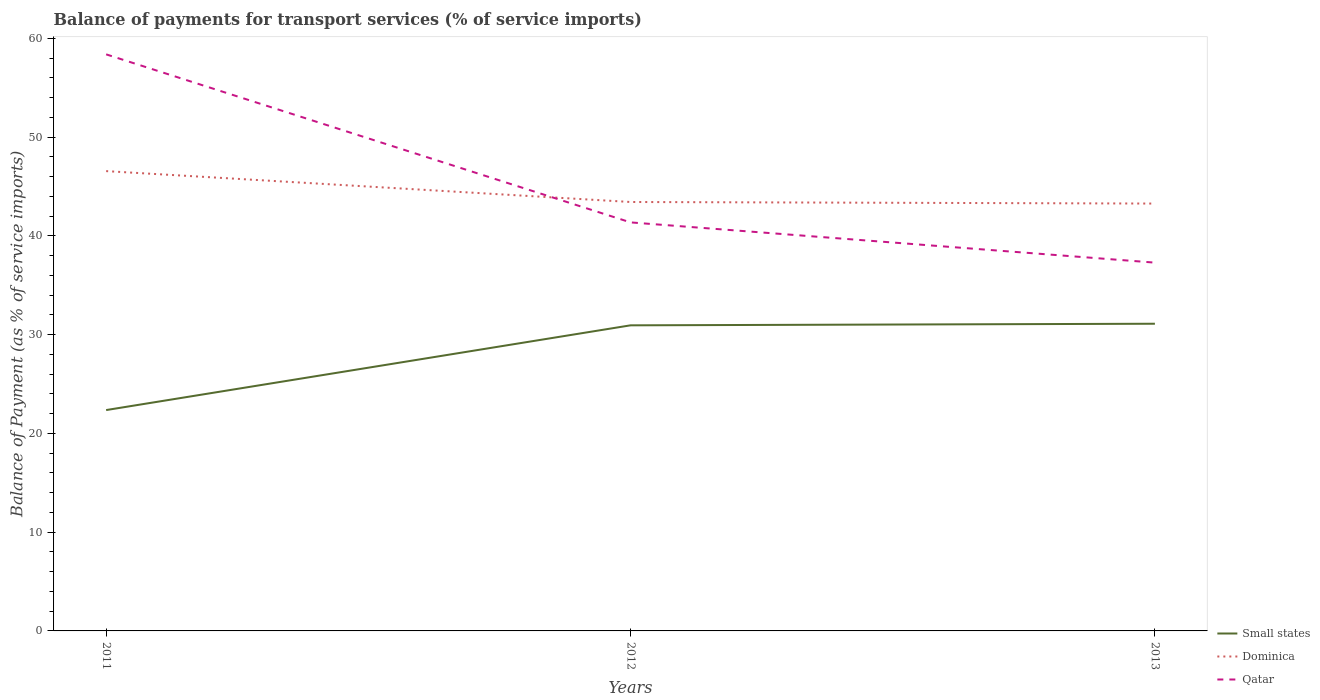Does the line corresponding to Small states intersect with the line corresponding to Qatar?
Keep it short and to the point. No. Is the number of lines equal to the number of legend labels?
Provide a short and direct response. Yes. Across all years, what is the maximum balance of payments for transport services in Small states?
Ensure brevity in your answer.  22.36. In which year was the balance of payments for transport services in Dominica maximum?
Ensure brevity in your answer.  2013. What is the total balance of payments for transport services in Dominica in the graph?
Your answer should be compact. 3.13. What is the difference between the highest and the second highest balance of payments for transport services in Dominica?
Provide a succinct answer. 3.28. What is the difference between the highest and the lowest balance of payments for transport services in Qatar?
Your answer should be compact. 1. Is the balance of payments for transport services in Small states strictly greater than the balance of payments for transport services in Qatar over the years?
Your answer should be compact. Yes. How many lines are there?
Make the answer very short. 3. How many years are there in the graph?
Your answer should be very brief. 3. What is the difference between two consecutive major ticks on the Y-axis?
Give a very brief answer. 10. Does the graph contain any zero values?
Provide a succinct answer. No. Where does the legend appear in the graph?
Your response must be concise. Bottom right. How many legend labels are there?
Your response must be concise. 3. How are the legend labels stacked?
Provide a short and direct response. Vertical. What is the title of the graph?
Your response must be concise. Balance of payments for transport services (% of service imports). Does "Tanzania" appear as one of the legend labels in the graph?
Offer a terse response. No. What is the label or title of the X-axis?
Give a very brief answer. Years. What is the label or title of the Y-axis?
Offer a terse response. Balance of Payment (as % of service imports). What is the Balance of Payment (as % of service imports) of Small states in 2011?
Your answer should be very brief. 22.36. What is the Balance of Payment (as % of service imports) of Dominica in 2011?
Your response must be concise. 46.55. What is the Balance of Payment (as % of service imports) of Qatar in 2011?
Offer a terse response. 58.37. What is the Balance of Payment (as % of service imports) of Small states in 2012?
Your answer should be very brief. 30.94. What is the Balance of Payment (as % of service imports) of Dominica in 2012?
Your response must be concise. 43.43. What is the Balance of Payment (as % of service imports) in Qatar in 2012?
Offer a very short reply. 41.36. What is the Balance of Payment (as % of service imports) of Small states in 2013?
Make the answer very short. 31.1. What is the Balance of Payment (as % of service imports) of Dominica in 2013?
Provide a short and direct response. 43.27. What is the Balance of Payment (as % of service imports) in Qatar in 2013?
Keep it short and to the point. 37.29. Across all years, what is the maximum Balance of Payment (as % of service imports) of Small states?
Ensure brevity in your answer.  31.1. Across all years, what is the maximum Balance of Payment (as % of service imports) in Dominica?
Give a very brief answer. 46.55. Across all years, what is the maximum Balance of Payment (as % of service imports) of Qatar?
Keep it short and to the point. 58.37. Across all years, what is the minimum Balance of Payment (as % of service imports) of Small states?
Make the answer very short. 22.36. Across all years, what is the minimum Balance of Payment (as % of service imports) in Dominica?
Your answer should be compact. 43.27. Across all years, what is the minimum Balance of Payment (as % of service imports) in Qatar?
Provide a succinct answer. 37.29. What is the total Balance of Payment (as % of service imports) of Small states in the graph?
Keep it short and to the point. 84.4. What is the total Balance of Payment (as % of service imports) in Dominica in the graph?
Give a very brief answer. 133.24. What is the total Balance of Payment (as % of service imports) in Qatar in the graph?
Give a very brief answer. 137.02. What is the difference between the Balance of Payment (as % of service imports) of Small states in 2011 and that in 2012?
Provide a succinct answer. -8.58. What is the difference between the Balance of Payment (as % of service imports) of Dominica in 2011 and that in 2012?
Ensure brevity in your answer.  3.13. What is the difference between the Balance of Payment (as % of service imports) of Qatar in 2011 and that in 2012?
Make the answer very short. 17.01. What is the difference between the Balance of Payment (as % of service imports) in Small states in 2011 and that in 2013?
Keep it short and to the point. -8.74. What is the difference between the Balance of Payment (as % of service imports) of Dominica in 2011 and that in 2013?
Your answer should be very brief. 3.28. What is the difference between the Balance of Payment (as % of service imports) of Qatar in 2011 and that in 2013?
Your response must be concise. 21.09. What is the difference between the Balance of Payment (as % of service imports) of Small states in 2012 and that in 2013?
Keep it short and to the point. -0.16. What is the difference between the Balance of Payment (as % of service imports) of Dominica in 2012 and that in 2013?
Give a very brief answer. 0.16. What is the difference between the Balance of Payment (as % of service imports) in Qatar in 2012 and that in 2013?
Give a very brief answer. 4.07. What is the difference between the Balance of Payment (as % of service imports) of Small states in 2011 and the Balance of Payment (as % of service imports) of Dominica in 2012?
Your answer should be very brief. -21.07. What is the difference between the Balance of Payment (as % of service imports) of Small states in 2011 and the Balance of Payment (as % of service imports) of Qatar in 2012?
Ensure brevity in your answer.  -19. What is the difference between the Balance of Payment (as % of service imports) in Dominica in 2011 and the Balance of Payment (as % of service imports) in Qatar in 2012?
Keep it short and to the point. 5.19. What is the difference between the Balance of Payment (as % of service imports) in Small states in 2011 and the Balance of Payment (as % of service imports) in Dominica in 2013?
Your answer should be compact. -20.91. What is the difference between the Balance of Payment (as % of service imports) of Small states in 2011 and the Balance of Payment (as % of service imports) of Qatar in 2013?
Offer a very short reply. -14.93. What is the difference between the Balance of Payment (as % of service imports) in Dominica in 2011 and the Balance of Payment (as % of service imports) in Qatar in 2013?
Your answer should be very brief. 9.27. What is the difference between the Balance of Payment (as % of service imports) in Small states in 2012 and the Balance of Payment (as % of service imports) in Dominica in 2013?
Your answer should be very brief. -12.33. What is the difference between the Balance of Payment (as % of service imports) of Small states in 2012 and the Balance of Payment (as % of service imports) of Qatar in 2013?
Your answer should be compact. -6.35. What is the difference between the Balance of Payment (as % of service imports) of Dominica in 2012 and the Balance of Payment (as % of service imports) of Qatar in 2013?
Your response must be concise. 6.14. What is the average Balance of Payment (as % of service imports) in Small states per year?
Your response must be concise. 28.13. What is the average Balance of Payment (as % of service imports) of Dominica per year?
Offer a very short reply. 44.41. What is the average Balance of Payment (as % of service imports) in Qatar per year?
Your response must be concise. 45.67. In the year 2011, what is the difference between the Balance of Payment (as % of service imports) of Small states and Balance of Payment (as % of service imports) of Dominica?
Your response must be concise. -24.19. In the year 2011, what is the difference between the Balance of Payment (as % of service imports) in Small states and Balance of Payment (as % of service imports) in Qatar?
Make the answer very short. -36.01. In the year 2011, what is the difference between the Balance of Payment (as % of service imports) of Dominica and Balance of Payment (as % of service imports) of Qatar?
Provide a short and direct response. -11.82. In the year 2012, what is the difference between the Balance of Payment (as % of service imports) of Small states and Balance of Payment (as % of service imports) of Dominica?
Make the answer very short. -12.49. In the year 2012, what is the difference between the Balance of Payment (as % of service imports) in Small states and Balance of Payment (as % of service imports) in Qatar?
Give a very brief answer. -10.42. In the year 2012, what is the difference between the Balance of Payment (as % of service imports) in Dominica and Balance of Payment (as % of service imports) in Qatar?
Your answer should be very brief. 2.07. In the year 2013, what is the difference between the Balance of Payment (as % of service imports) of Small states and Balance of Payment (as % of service imports) of Dominica?
Provide a succinct answer. -12.17. In the year 2013, what is the difference between the Balance of Payment (as % of service imports) in Small states and Balance of Payment (as % of service imports) in Qatar?
Your answer should be compact. -6.19. In the year 2013, what is the difference between the Balance of Payment (as % of service imports) in Dominica and Balance of Payment (as % of service imports) in Qatar?
Make the answer very short. 5.98. What is the ratio of the Balance of Payment (as % of service imports) in Small states in 2011 to that in 2012?
Make the answer very short. 0.72. What is the ratio of the Balance of Payment (as % of service imports) of Dominica in 2011 to that in 2012?
Your response must be concise. 1.07. What is the ratio of the Balance of Payment (as % of service imports) in Qatar in 2011 to that in 2012?
Offer a very short reply. 1.41. What is the ratio of the Balance of Payment (as % of service imports) of Small states in 2011 to that in 2013?
Ensure brevity in your answer.  0.72. What is the ratio of the Balance of Payment (as % of service imports) in Dominica in 2011 to that in 2013?
Your response must be concise. 1.08. What is the ratio of the Balance of Payment (as % of service imports) in Qatar in 2011 to that in 2013?
Your answer should be compact. 1.57. What is the ratio of the Balance of Payment (as % of service imports) in Small states in 2012 to that in 2013?
Provide a short and direct response. 0.99. What is the ratio of the Balance of Payment (as % of service imports) in Qatar in 2012 to that in 2013?
Make the answer very short. 1.11. What is the difference between the highest and the second highest Balance of Payment (as % of service imports) in Small states?
Offer a terse response. 0.16. What is the difference between the highest and the second highest Balance of Payment (as % of service imports) of Dominica?
Your answer should be compact. 3.13. What is the difference between the highest and the second highest Balance of Payment (as % of service imports) in Qatar?
Make the answer very short. 17.01. What is the difference between the highest and the lowest Balance of Payment (as % of service imports) in Small states?
Give a very brief answer. 8.74. What is the difference between the highest and the lowest Balance of Payment (as % of service imports) in Dominica?
Make the answer very short. 3.28. What is the difference between the highest and the lowest Balance of Payment (as % of service imports) of Qatar?
Your answer should be very brief. 21.09. 